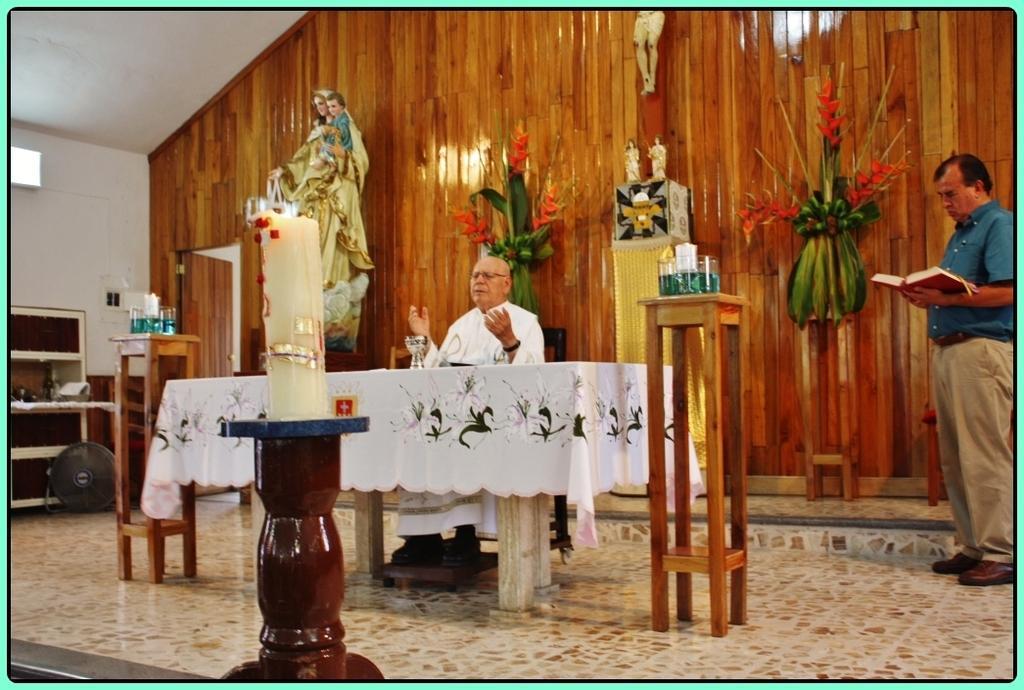Could you give a brief overview of what you see in this image? A picture of a room. This man is sitting on chair. In-front of this man there is a table with cloth. This is candle with fire. These are statues. On this table there are glasses. Flowers are attached to the wall. This is door. This man is standing and holds a book. 